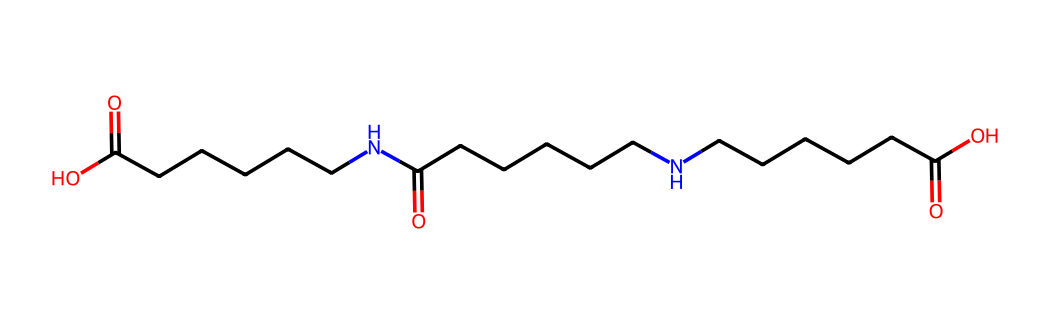How many carbon atoms are in this molecule? By examining the SMILES representation, we identify that the longest carbon chain has six carbon atoms (CCCCCC) and it is repeated multiple times, and there are also carbonyl groups (C=O) which indicate additional carbon atoms. A careful count of total carbon positions gives us a total of twenty carbon atoms.
Answer: twenty What types of bonds are present in this chemical structure? The SMILES notation reveals both single (sigma) and double (pi) bonds; the single bonds connect carbon atoms and nitrogen, while the double bonds connect carbon to oxygen in the carbonyl groups (C=O).
Answer: single and double What is the functional group present at the ends of the molecule? The molecule ends with a carboxylic acid functionality (indicated by -COOH) which is part of the repeating units connected to the nylon backbone.
Answer: carboxylic acid Is this molecule likely to be thermoplastic or thermosetting? The presence of flexible amide linkages and the ability to soften upon heating suggests that the molecule can be classified as thermoplastic rather than thermosetting, as thermoplastics can be molded upon heating.
Answer: thermoplastic What property contributes to the protective nature of nylon fibers? The amide linkages (–C(=O)N–) in the nylon structure provide strength and durability, contributing significantly to the tensile strength and thermal stability of the fibers, making them suitable for protective clothing.
Answer: strength and durability How many nitrogen atoms are present in the structure? The SMILES notation includes "N" which indicates the presence of nitrogen atoms. Counting these within the structure shows there are three nitrogen atoms in total present.
Answer: three 